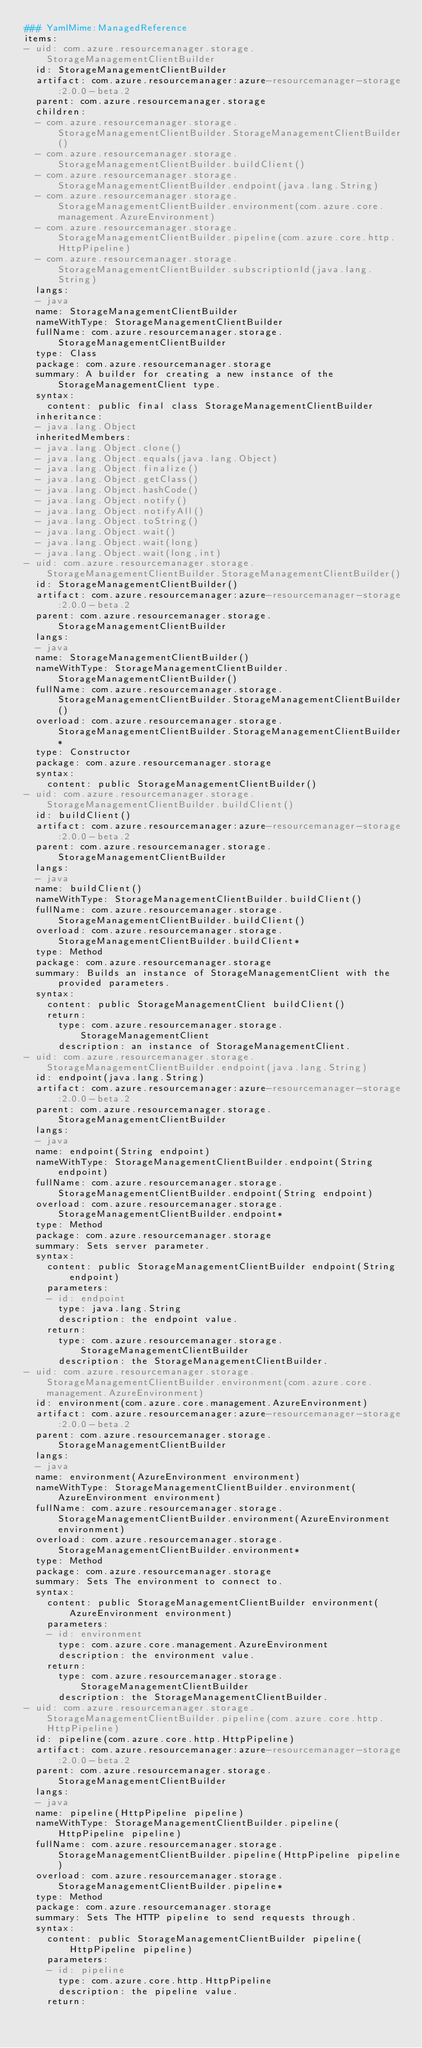<code> <loc_0><loc_0><loc_500><loc_500><_YAML_>### YamlMime:ManagedReference
items:
- uid: com.azure.resourcemanager.storage.StorageManagementClientBuilder
  id: StorageManagementClientBuilder
  artifact: com.azure.resourcemanager:azure-resourcemanager-storage:2.0.0-beta.2
  parent: com.azure.resourcemanager.storage
  children:
  - com.azure.resourcemanager.storage.StorageManagementClientBuilder.StorageManagementClientBuilder()
  - com.azure.resourcemanager.storage.StorageManagementClientBuilder.buildClient()
  - com.azure.resourcemanager.storage.StorageManagementClientBuilder.endpoint(java.lang.String)
  - com.azure.resourcemanager.storage.StorageManagementClientBuilder.environment(com.azure.core.management.AzureEnvironment)
  - com.azure.resourcemanager.storage.StorageManagementClientBuilder.pipeline(com.azure.core.http.HttpPipeline)
  - com.azure.resourcemanager.storage.StorageManagementClientBuilder.subscriptionId(java.lang.String)
  langs:
  - java
  name: StorageManagementClientBuilder
  nameWithType: StorageManagementClientBuilder
  fullName: com.azure.resourcemanager.storage.StorageManagementClientBuilder
  type: Class
  package: com.azure.resourcemanager.storage
  summary: A builder for creating a new instance of the StorageManagementClient type.
  syntax:
    content: public final class StorageManagementClientBuilder
  inheritance:
  - java.lang.Object
  inheritedMembers:
  - java.lang.Object.clone()
  - java.lang.Object.equals(java.lang.Object)
  - java.lang.Object.finalize()
  - java.lang.Object.getClass()
  - java.lang.Object.hashCode()
  - java.lang.Object.notify()
  - java.lang.Object.notifyAll()
  - java.lang.Object.toString()
  - java.lang.Object.wait()
  - java.lang.Object.wait(long)
  - java.lang.Object.wait(long,int)
- uid: com.azure.resourcemanager.storage.StorageManagementClientBuilder.StorageManagementClientBuilder()
  id: StorageManagementClientBuilder()
  artifact: com.azure.resourcemanager:azure-resourcemanager-storage:2.0.0-beta.2
  parent: com.azure.resourcemanager.storage.StorageManagementClientBuilder
  langs:
  - java
  name: StorageManagementClientBuilder()
  nameWithType: StorageManagementClientBuilder.StorageManagementClientBuilder()
  fullName: com.azure.resourcemanager.storage.StorageManagementClientBuilder.StorageManagementClientBuilder()
  overload: com.azure.resourcemanager.storage.StorageManagementClientBuilder.StorageManagementClientBuilder*
  type: Constructor
  package: com.azure.resourcemanager.storage
  syntax:
    content: public StorageManagementClientBuilder()
- uid: com.azure.resourcemanager.storage.StorageManagementClientBuilder.buildClient()
  id: buildClient()
  artifact: com.azure.resourcemanager:azure-resourcemanager-storage:2.0.0-beta.2
  parent: com.azure.resourcemanager.storage.StorageManagementClientBuilder
  langs:
  - java
  name: buildClient()
  nameWithType: StorageManagementClientBuilder.buildClient()
  fullName: com.azure.resourcemanager.storage.StorageManagementClientBuilder.buildClient()
  overload: com.azure.resourcemanager.storage.StorageManagementClientBuilder.buildClient*
  type: Method
  package: com.azure.resourcemanager.storage
  summary: Builds an instance of StorageManagementClient with the provided parameters.
  syntax:
    content: public StorageManagementClient buildClient()
    return:
      type: com.azure.resourcemanager.storage.StorageManagementClient
      description: an instance of StorageManagementClient.
- uid: com.azure.resourcemanager.storage.StorageManagementClientBuilder.endpoint(java.lang.String)
  id: endpoint(java.lang.String)
  artifact: com.azure.resourcemanager:azure-resourcemanager-storage:2.0.0-beta.2
  parent: com.azure.resourcemanager.storage.StorageManagementClientBuilder
  langs:
  - java
  name: endpoint(String endpoint)
  nameWithType: StorageManagementClientBuilder.endpoint(String endpoint)
  fullName: com.azure.resourcemanager.storage.StorageManagementClientBuilder.endpoint(String endpoint)
  overload: com.azure.resourcemanager.storage.StorageManagementClientBuilder.endpoint*
  type: Method
  package: com.azure.resourcemanager.storage
  summary: Sets server parameter.
  syntax:
    content: public StorageManagementClientBuilder endpoint(String endpoint)
    parameters:
    - id: endpoint
      type: java.lang.String
      description: the endpoint value.
    return:
      type: com.azure.resourcemanager.storage.StorageManagementClientBuilder
      description: the StorageManagementClientBuilder.
- uid: com.azure.resourcemanager.storage.StorageManagementClientBuilder.environment(com.azure.core.management.AzureEnvironment)
  id: environment(com.azure.core.management.AzureEnvironment)
  artifact: com.azure.resourcemanager:azure-resourcemanager-storage:2.0.0-beta.2
  parent: com.azure.resourcemanager.storage.StorageManagementClientBuilder
  langs:
  - java
  name: environment(AzureEnvironment environment)
  nameWithType: StorageManagementClientBuilder.environment(AzureEnvironment environment)
  fullName: com.azure.resourcemanager.storage.StorageManagementClientBuilder.environment(AzureEnvironment environment)
  overload: com.azure.resourcemanager.storage.StorageManagementClientBuilder.environment*
  type: Method
  package: com.azure.resourcemanager.storage
  summary: Sets The environment to connect to.
  syntax:
    content: public StorageManagementClientBuilder environment(AzureEnvironment environment)
    parameters:
    - id: environment
      type: com.azure.core.management.AzureEnvironment
      description: the environment value.
    return:
      type: com.azure.resourcemanager.storage.StorageManagementClientBuilder
      description: the StorageManagementClientBuilder.
- uid: com.azure.resourcemanager.storage.StorageManagementClientBuilder.pipeline(com.azure.core.http.HttpPipeline)
  id: pipeline(com.azure.core.http.HttpPipeline)
  artifact: com.azure.resourcemanager:azure-resourcemanager-storage:2.0.0-beta.2
  parent: com.azure.resourcemanager.storage.StorageManagementClientBuilder
  langs:
  - java
  name: pipeline(HttpPipeline pipeline)
  nameWithType: StorageManagementClientBuilder.pipeline(HttpPipeline pipeline)
  fullName: com.azure.resourcemanager.storage.StorageManagementClientBuilder.pipeline(HttpPipeline pipeline)
  overload: com.azure.resourcemanager.storage.StorageManagementClientBuilder.pipeline*
  type: Method
  package: com.azure.resourcemanager.storage
  summary: Sets The HTTP pipeline to send requests through.
  syntax:
    content: public StorageManagementClientBuilder pipeline(HttpPipeline pipeline)
    parameters:
    - id: pipeline
      type: com.azure.core.http.HttpPipeline
      description: the pipeline value.
    return:</code> 